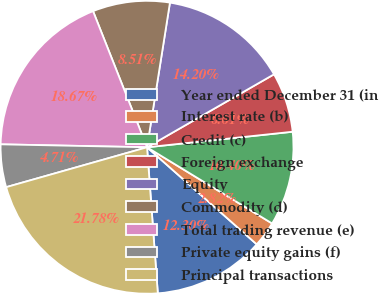Convert chart. <chart><loc_0><loc_0><loc_500><loc_500><pie_chart><fcel>Year ended December 31 (in<fcel>Interest rate (b)<fcel>Credit (c)<fcel>Foreign exchange<fcel>Equity<fcel>Commodity (d)<fcel>Total trading revenue (e)<fcel>Private equity gains (f)<fcel>Principal transactions<nl><fcel>12.3%<fcel>2.82%<fcel>10.4%<fcel>6.61%<fcel>14.2%<fcel>8.51%<fcel>18.67%<fcel>4.71%<fcel>21.78%<nl></chart> 